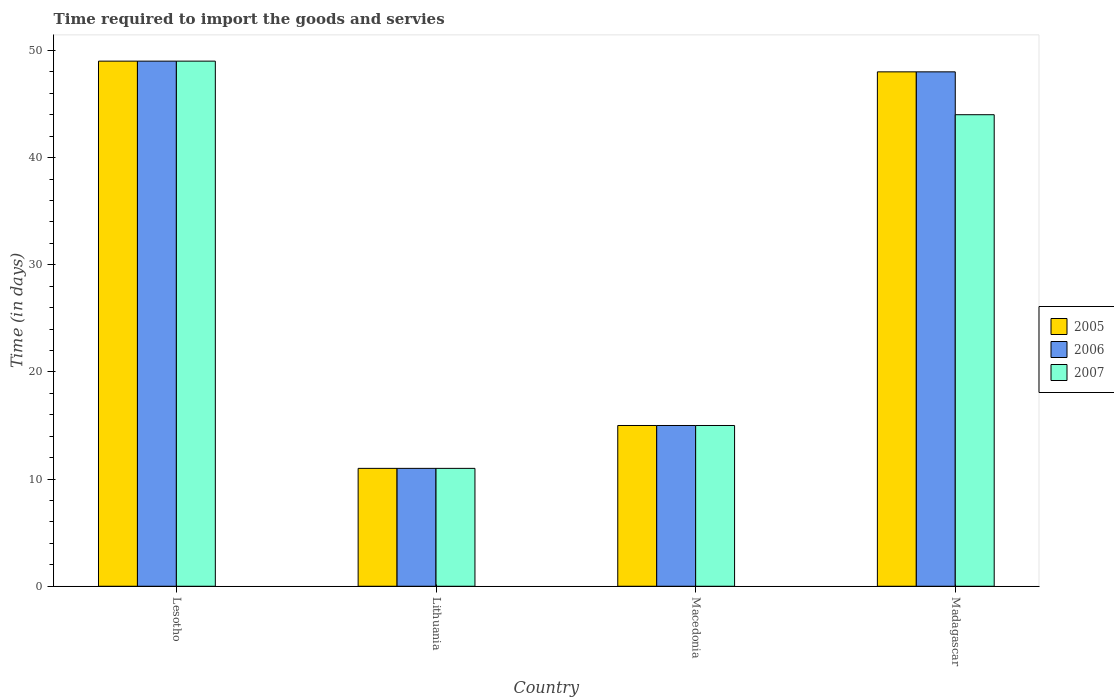How many different coloured bars are there?
Keep it short and to the point. 3. How many groups of bars are there?
Your answer should be very brief. 4. Are the number of bars on each tick of the X-axis equal?
Keep it short and to the point. Yes. How many bars are there on the 2nd tick from the left?
Make the answer very short. 3. What is the label of the 2nd group of bars from the left?
Offer a terse response. Lithuania. In how many cases, is the number of bars for a given country not equal to the number of legend labels?
Keep it short and to the point. 0. Across all countries, what is the maximum number of days required to import the goods and services in 2007?
Offer a very short reply. 49. Across all countries, what is the minimum number of days required to import the goods and services in 2006?
Make the answer very short. 11. In which country was the number of days required to import the goods and services in 2005 maximum?
Give a very brief answer. Lesotho. In which country was the number of days required to import the goods and services in 2007 minimum?
Your response must be concise. Lithuania. What is the total number of days required to import the goods and services in 2006 in the graph?
Ensure brevity in your answer.  123. What is the difference between the number of days required to import the goods and services in 2007 in Lithuania and that in Madagascar?
Provide a succinct answer. -33. What is the difference between the number of days required to import the goods and services in 2007 in Madagascar and the number of days required to import the goods and services in 2005 in Macedonia?
Keep it short and to the point. 29. What is the average number of days required to import the goods and services in 2005 per country?
Keep it short and to the point. 30.75. What is the difference between the number of days required to import the goods and services of/in 2005 and number of days required to import the goods and services of/in 2006 in Macedonia?
Your answer should be compact. 0. What is the ratio of the number of days required to import the goods and services in 2006 in Lithuania to that in Macedonia?
Your answer should be very brief. 0.73. What is the difference between the highest and the lowest number of days required to import the goods and services in 2006?
Your answer should be very brief. 38. What does the 3rd bar from the left in Macedonia represents?
Your answer should be very brief. 2007. Are the values on the major ticks of Y-axis written in scientific E-notation?
Ensure brevity in your answer.  No. Where does the legend appear in the graph?
Your answer should be compact. Center right. How many legend labels are there?
Your answer should be very brief. 3. What is the title of the graph?
Your response must be concise. Time required to import the goods and servies. Does "1974" appear as one of the legend labels in the graph?
Your answer should be very brief. No. What is the label or title of the X-axis?
Provide a short and direct response. Country. What is the label or title of the Y-axis?
Make the answer very short. Time (in days). What is the Time (in days) in 2005 in Lesotho?
Ensure brevity in your answer.  49. What is the Time (in days) in 2006 in Lesotho?
Your answer should be compact. 49. What is the Time (in days) of 2007 in Lithuania?
Your answer should be compact. 11. What is the Time (in days) of 2006 in Macedonia?
Provide a succinct answer. 15. Across all countries, what is the maximum Time (in days) in 2006?
Provide a short and direct response. 49. Across all countries, what is the minimum Time (in days) of 2005?
Your response must be concise. 11. Across all countries, what is the minimum Time (in days) of 2006?
Provide a short and direct response. 11. What is the total Time (in days) in 2005 in the graph?
Provide a succinct answer. 123. What is the total Time (in days) of 2006 in the graph?
Make the answer very short. 123. What is the total Time (in days) of 2007 in the graph?
Make the answer very short. 119. What is the difference between the Time (in days) of 2006 in Lesotho and that in Lithuania?
Keep it short and to the point. 38. What is the difference between the Time (in days) in 2005 in Lesotho and that in Macedonia?
Provide a succinct answer. 34. What is the difference between the Time (in days) in 2005 in Lesotho and that in Madagascar?
Your answer should be very brief. 1. What is the difference between the Time (in days) in 2007 in Lesotho and that in Madagascar?
Make the answer very short. 5. What is the difference between the Time (in days) of 2005 in Lithuania and that in Macedonia?
Your response must be concise. -4. What is the difference between the Time (in days) in 2006 in Lithuania and that in Macedonia?
Make the answer very short. -4. What is the difference between the Time (in days) in 2007 in Lithuania and that in Macedonia?
Make the answer very short. -4. What is the difference between the Time (in days) in 2005 in Lithuania and that in Madagascar?
Your response must be concise. -37. What is the difference between the Time (in days) of 2006 in Lithuania and that in Madagascar?
Provide a succinct answer. -37. What is the difference between the Time (in days) in 2007 in Lithuania and that in Madagascar?
Offer a very short reply. -33. What is the difference between the Time (in days) in 2005 in Macedonia and that in Madagascar?
Give a very brief answer. -33. What is the difference between the Time (in days) in 2006 in Macedonia and that in Madagascar?
Make the answer very short. -33. What is the difference between the Time (in days) of 2005 in Lesotho and the Time (in days) of 2006 in Lithuania?
Your answer should be very brief. 38. What is the difference between the Time (in days) in 2005 in Lesotho and the Time (in days) in 2007 in Lithuania?
Your answer should be very brief. 38. What is the difference between the Time (in days) of 2005 in Lesotho and the Time (in days) of 2006 in Macedonia?
Your response must be concise. 34. What is the difference between the Time (in days) in 2006 in Lesotho and the Time (in days) in 2007 in Macedonia?
Make the answer very short. 34. What is the difference between the Time (in days) of 2005 in Lesotho and the Time (in days) of 2007 in Madagascar?
Provide a succinct answer. 5. What is the difference between the Time (in days) of 2006 in Lesotho and the Time (in days) of 2007 in Madagascar?
Your answer should be very brief. 5. What is the difference between the Time (in days) in 2005 in Lithuania and the Time (in days) in 2007 in Macedonia?
Your answer should be compact. -4. What is the difference between the Time (in days) in 2005 in Lithuania and the Time (in days) in 2006 in Madagascar?
Make the answer very short. -37. What is the difference between the Time (in days) of 2005 in Lithuania and the Time (in days) of 2007 in Madagascar?
Your answer should be compact. -33. What is the difference between the Time (in days) of 2006 in Lithuania and the Time (in days) of 2007 in Madagascar?
Your response must be concise. -33. What is the difference between the Time (in days) in 2005 in Macedonia and the Time (in days) in 2006 in Madagascar?
Your answer should be very brief. -33. What is the average Time (in days) of 2005 per country?
Offer a terse response. 30.75. What is the average Time (in days) in 2006 per country?
Make the answer very short. 30.75. What is the average Time (in days) of 2007 per country?
Offer a terse response. 29.75. What is the difference between the Time (in days) of 2005 and Time (in days) of 2007 in Lesotho?
Your answer should be very brief. 0. What is the difference between the Time (in days) in 2005 and Time (in days) in 2006 in Lithuania?
Provide a short and direct response. 0. What is the difference between the Time (in days) in 2006 and Time (in days) in 2007 in Lithuania?
Your answer should be very brief. 0. What is the difference between the Time (in days) of 2005 and Time (in days) of 2006 in Macedonia?
Your answer should be compact. 0. What is the difference between the Time (in days) of 2006 and Time (in days) of 2007 in Macedonia?
Make the answer very short. 0. What is the difference between the Time (in days) in 2005 and Time (in days) in 2006 in Madagascar?
Your answer should be very brief. 0. What is the difference between the Time (in days) of 2005 and Time (in days) of 2007 in Madagascar?
Provide a short and direct response. 4. What is the difference between the Time (in days) in 2006 and Time (in days) in 2007 in Madagascar?
Your answer should be very brief. 4. What is the ratio of the Time (in days) in 2005 in Lesotho to that in Lithuania?
Offer a terse response. 4.45. What is the ratio of the Time (in days) in 2006 in Lesotho to that in Lithuania?
Ensure brevity in your answer.  4.45. What is the ratio of the Time (in days) of 2007 in Lesotho to that in Lithuania?
Your answer should be compact. 4.45. What is the ratio of the Time (in days) in 2005 in Lesotho to that in Macedonia?
Make the answer very short. 3.27. What is the ratio of the Time (in days) of 2006 in Lesotho to that in Macedonia?
Provide a succinct answer. 3.27. What is the ratio of the Time (in days) of 2007 in Lesotho to that in Macedonia?
Provide a short and direct response. 3.27. What is the ratio of the Time (in days) in 2005 in Lesotho to that in Madagascar?
Keep it short and to the point. 1.02. What is the ratio of the Time (in days) of 2006 in Lesotho to that in Madagascar?
Ensure brevity in your answer.  1.02. What is the ratio of the Time (in days) of 2007 in Lesotho to that in Madagascar?
Your answer should be compact. 1.11. What is the ratio of the Time (in days) of 2005 in Lithuania to that in Macedonia?
Your answer should be compact. 0.73. What is the ratio of the Time (in days) in 2006 in Lithuania to that in Macedonia?
Ensure brevity in your answer.  0.73. What is the ratio of the Time (in days) in 2007 in Lithuania to that in Macedonia?
Your answer should be very brief. 0.73. What is the ratio of the Time (in days) in 2005 in Lithuania to that in Madagascar?
Your answer should be compact. 0.23. What is the ratio of the Time (in days) in 2006 in Lithuania to that in Madagascar?
Give a very brief answer. 0.23. What is the ratio of the Time (in days) in 2005 in Macedonia to that in Madagascar?
Give a very brief answer. 0.31. What is the ratio of the Time (in days) of 2006 in Macedonia to that in Madagascar?
Make the answer very short. 0.31. What is the ratio of the Time (in days) of 2007 in Macedonia to that in Madagascar?
Your response must be concise. 0.34. What is the difference between the highest and the second highest Time (in days) of 2005?
Keep it short and to the point. 1. What is the difference between the highest and the second highest Time (in days) in 2006?
Keep it short and to the point. 1. What is the difference between the highest and the lowest Time (in days) of 2005?
Your answer should be very brief. 38. What is the difference between the highest and the lowest Time (in days) in 2006?
Your answer should be very brief. 38. 